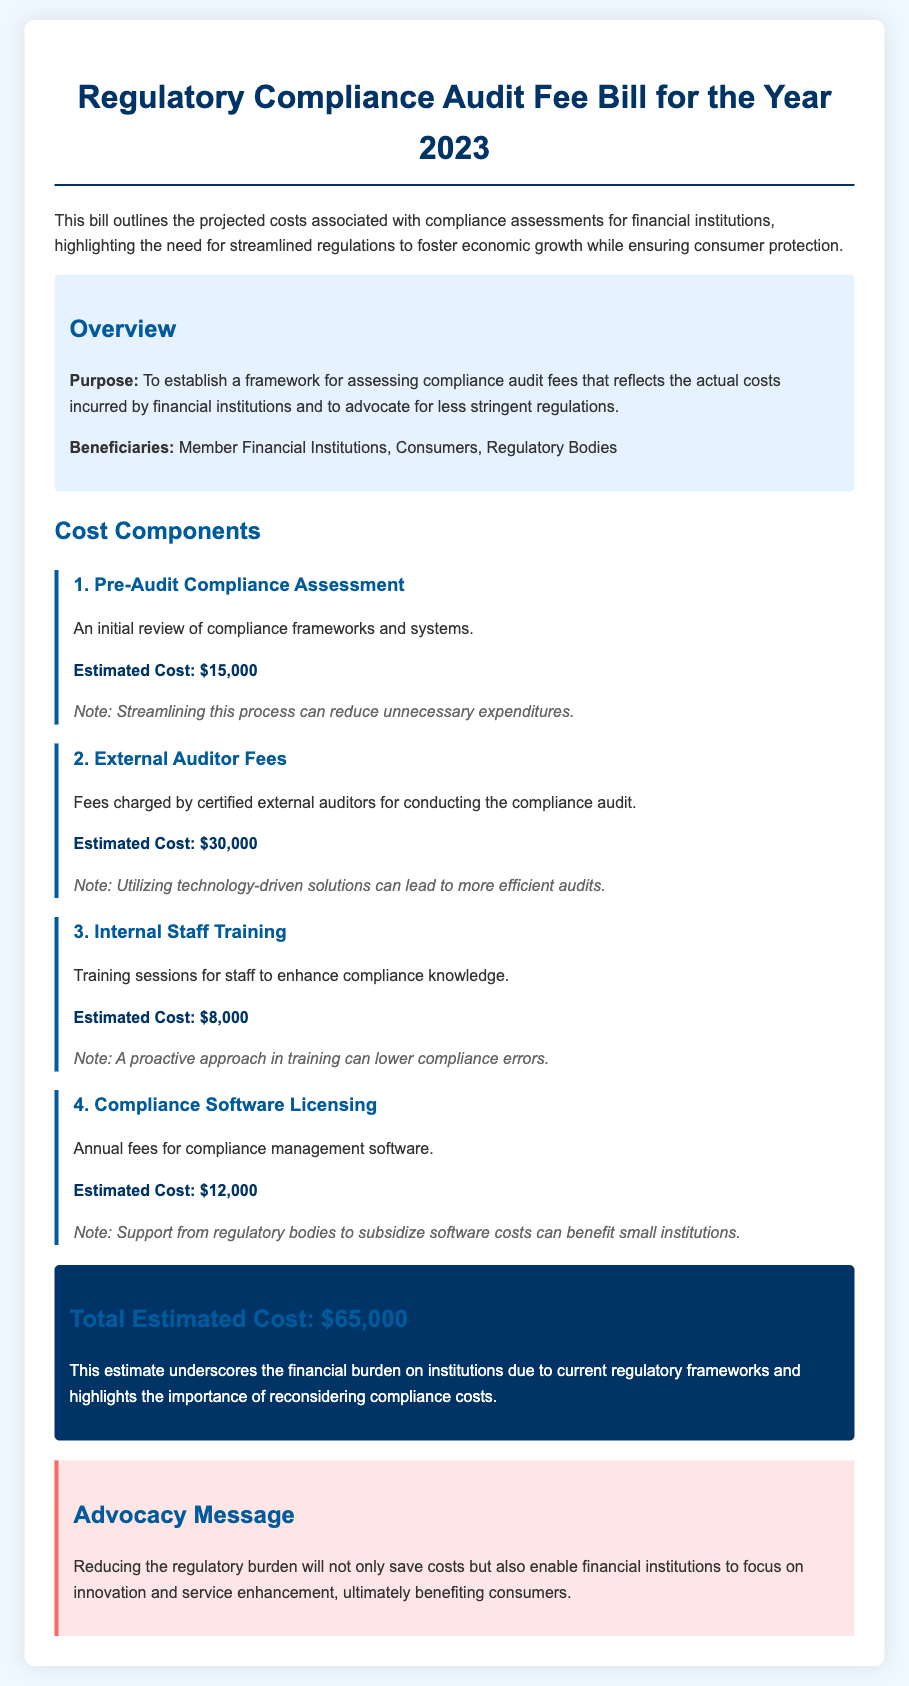what is the estimated cost for Pre-Audit Compliance Assessment? The estimated cost for Pre-Audit Compliance Assessment is listed in the document as a specific amount.
Answer: $15,000 what is the total estimated cost outlined in the bill? The total estimated cost is provided in the conclusion of the document.
Answer: $65,000 who are the beneficiaries of this bill? The beneficiaries are explicitly mentioned in the overview section of the document.
Answer: Member Financial Institutions, Consumers, Regulatory Bodies what is the cost associated with External Auditor Fees? The cost for External Auditor Fees is detailed as a specific amount in the cost components section.
Answer: $30,000 what benefit does training provide according to the bill? The document states the benefits of training in relation to compliance.
Answer: Lower compliance errors how much is allocated for Compliance Software Licensing? The amount allocated for Compliance Software Licensing is stated precisely in the document.
Answer: $12,000 what is the purpose of this bill? The purpose of the bill is clearly articulated in the overview section.
Answer: To establish a framework for assessing compliance audit fees how can technology improve audit efficiency? The document suggests that utilizing technology can enhance the efficiency of audits.
Answer: More efficient audits what does the advocacy message highlight? The advocacy message summarizes the main point in relation to costs and institutional focus.
Answer: Save costs and enable innovation 